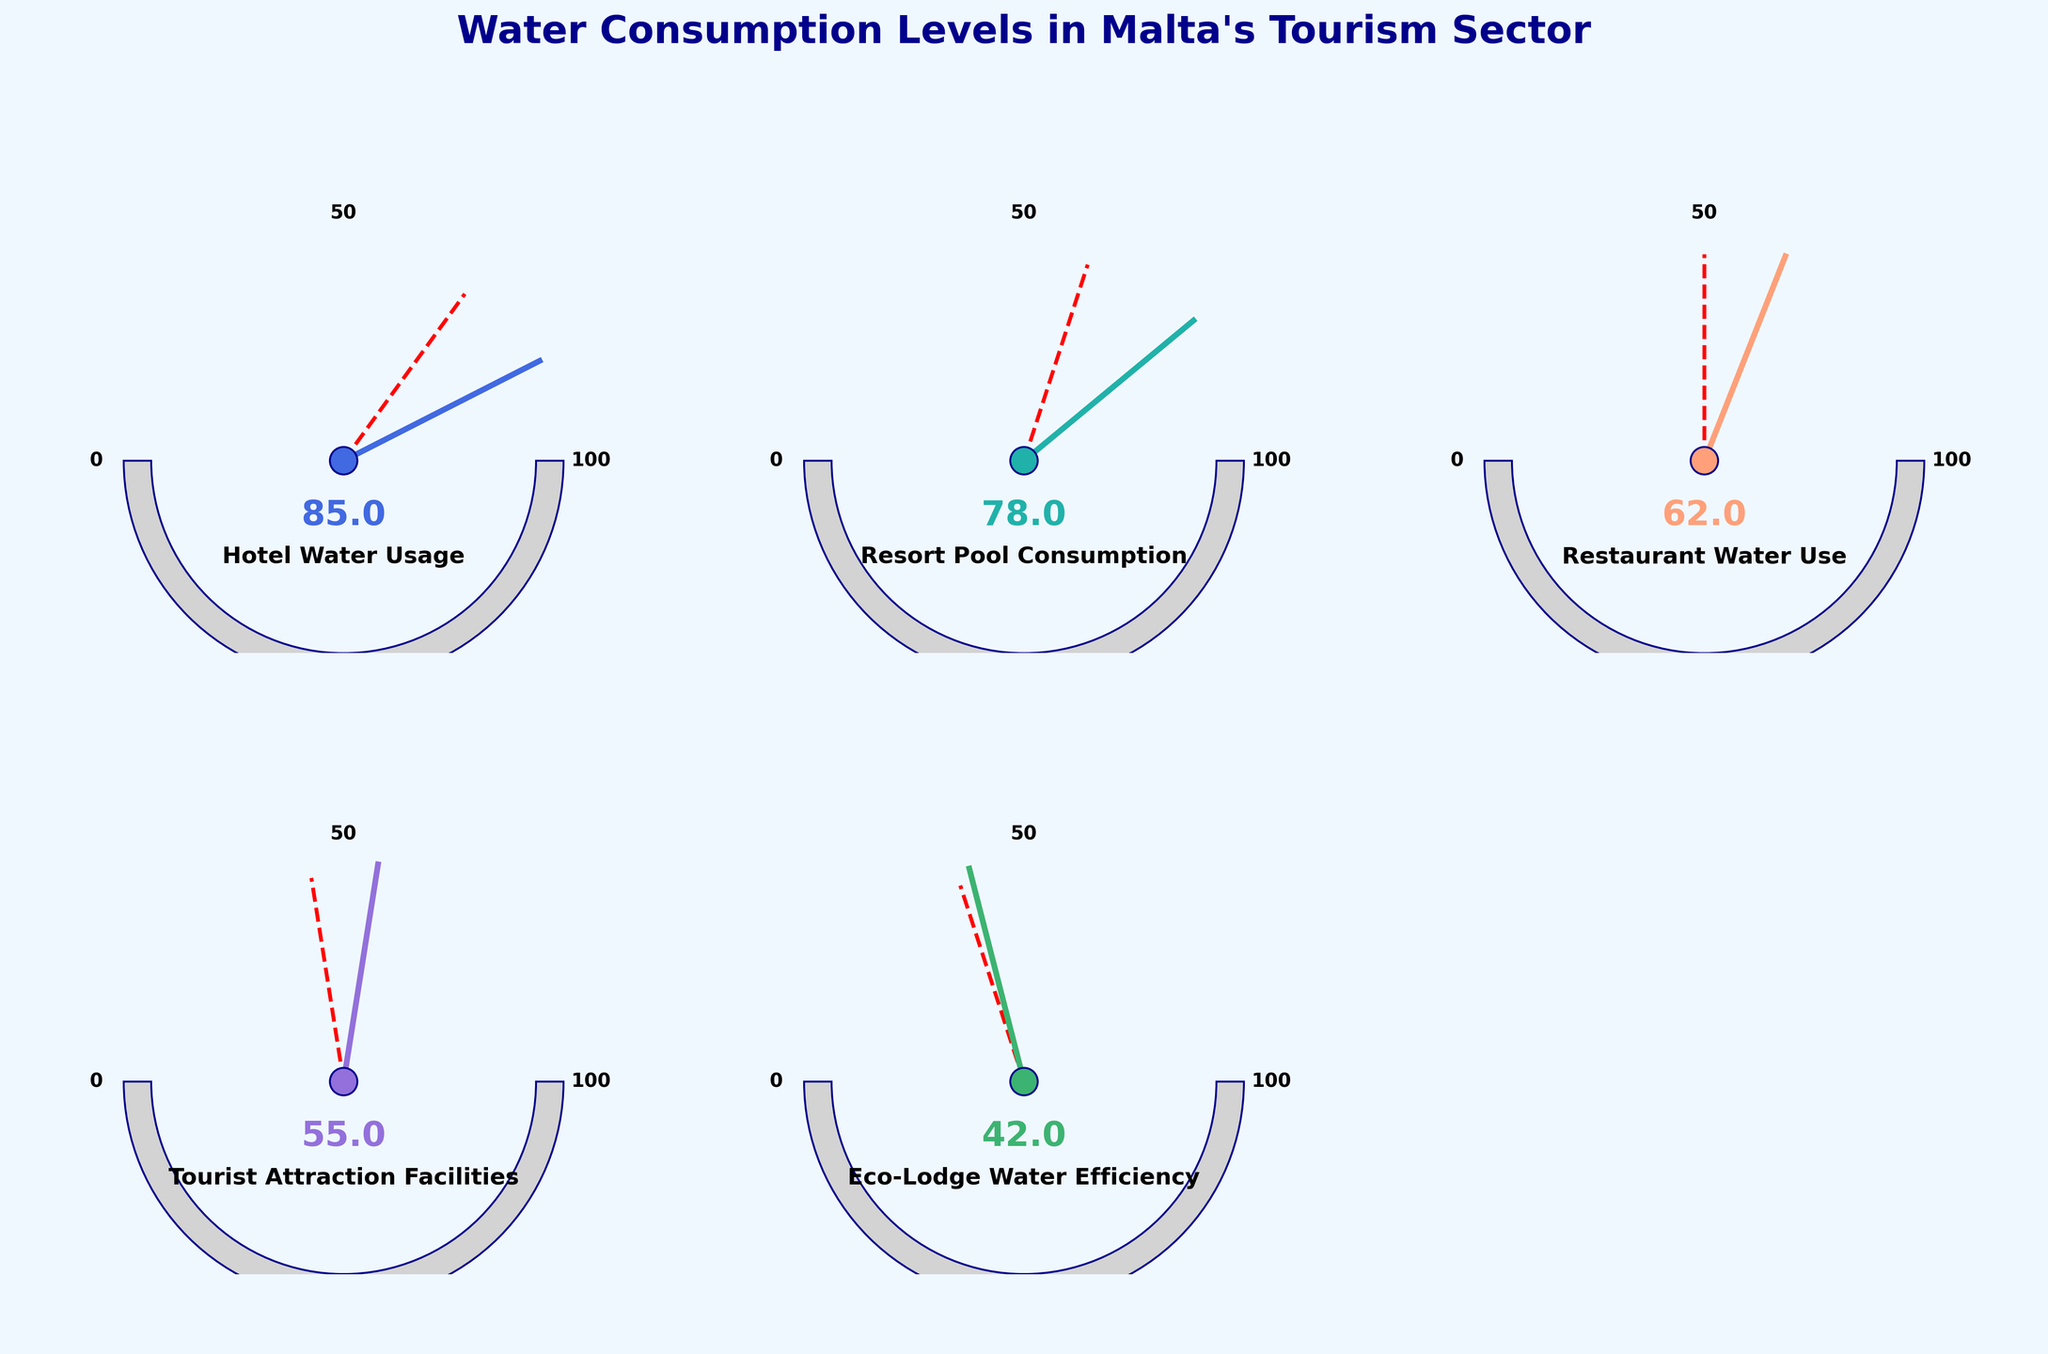What's the current value for Hotel Water Usage? The figure shows various categories with their respective gauges indicating current values. For Hotel Water Usage, the gauge points to 85.
Answer: 85 How much is the Resort Pool Consumption above the target value? The target value for Resort Pool Consumption is 60, and the current value is 78. Subtracting 60 from 78 gives us the difference.
Answer: 18 Which category has achieved the closest to its target? By evaluating the difference between current and target values for each category, we find that Eco-Lodge Water Efficiency has the smallest difference (42 - 40 = 2).
Answer: Eco-Lodge Water Efficiency What is the maximum value shown in each gauge? Each gauge has a maximum value indicator marked at 100.
Answer: 100 Compare the water usage of Tourist Attraction Facilities to Restaurant Water Use. Which one is higher? Looking at the current values, Tourist Attraction Facilities have a value of 55, and Restaurant Water Use has a value of 62. Therefore, Restaurant Water Use is higher.
Answer: Restaurant Water Use How many categories have current values that exceed their targets? The categories where current values exceed the targets are Hotel Water Usage, Resort Pool Consumption, Restaurant Water Use, and Tourist Attraction Facilities. That's a total of four categories.
Answer: 4 What is the range of target values across all categories? The target values across categories are 70, 60, 50, 45, and 40. The range is calculated as the difference between the maximum (70) and the minimum (40) value.
Answer: 30 Is there any category where the current value is below the target? By comparing current values to their respective targets, we see that no category's current value is below the target.
Answer: No Which category's gauge shows the lowest current value? The category with the lowest current value is Eco-Lodge Water Efficiency, with a value of 42.
Answer: Eco-Lodge Water Efficiency What is the average current value across all categories? To find the average, sum the current values of all categories: 85 + 78 + 62 + 55 + 42 = 322. Divide this by the number of categories (5): 322 / 5.
Answer: 64.4 